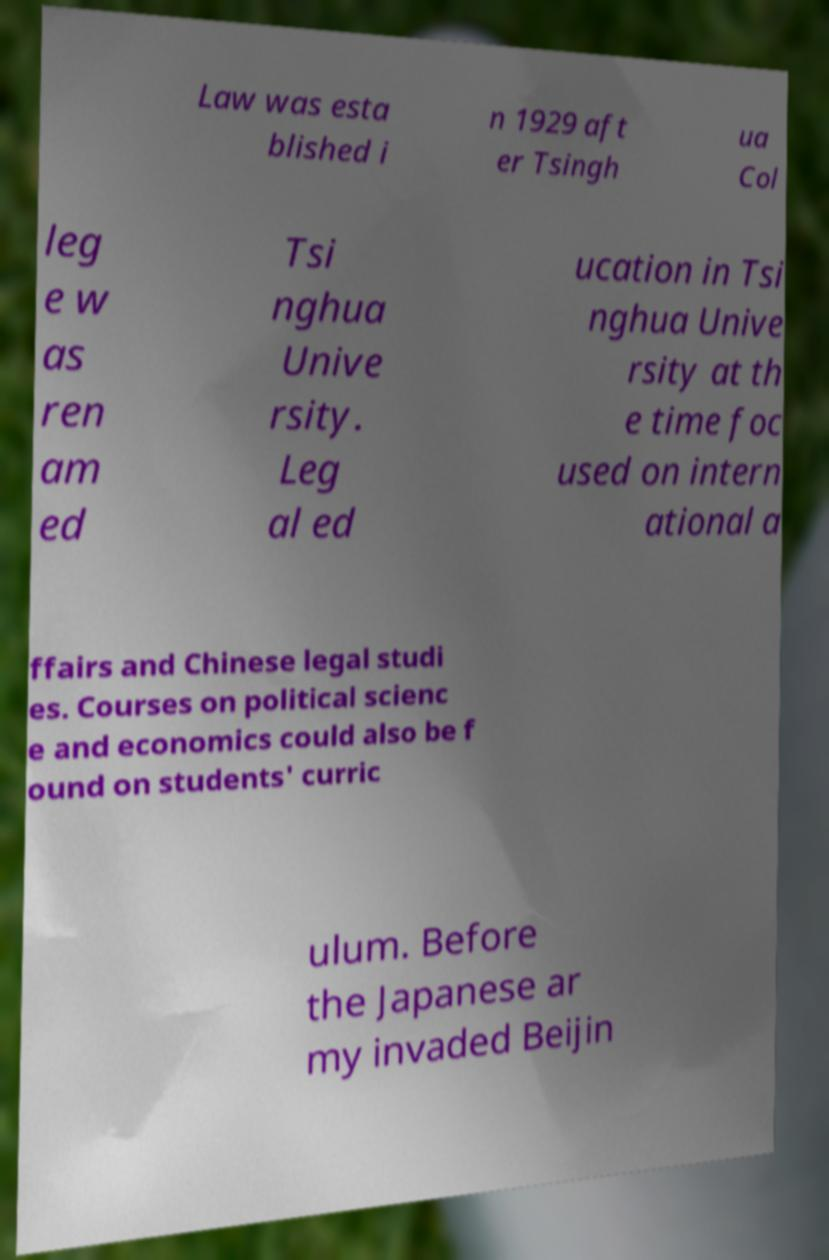I need the written content from this picture converted into text. Can you do that? Law was esta blished i n 1929 aft er Tsingh ua Col leg e w as ren am ed Tsi nghua Unive rsity. Leg al ed ucation in Tsi nghua Unive rsity at th e time foc used on intern ational a ffairs and Chinese legal studi es. Courses on political scienc e and economics could also be f ound on students' curric ulum. Before the Japanese ar my invaded Beijin 